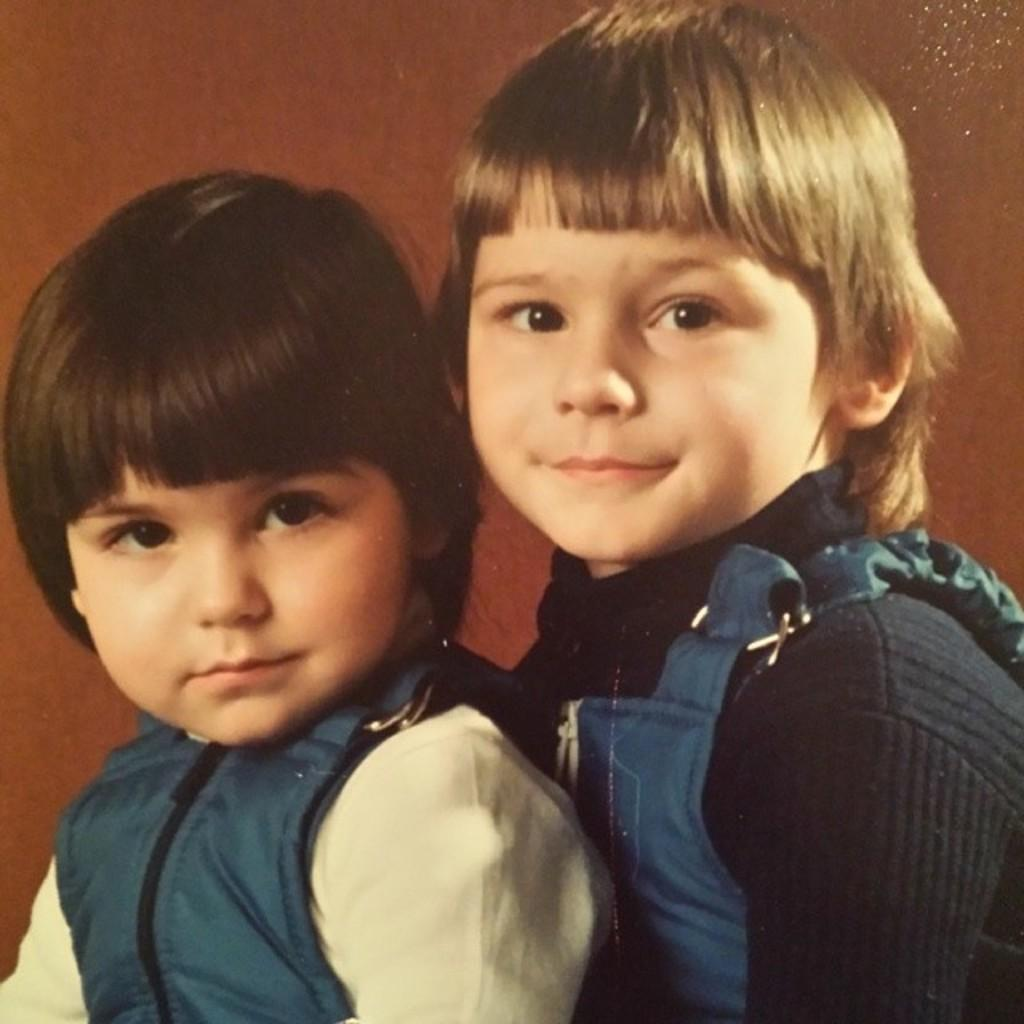How many children are present in the image? There are two kids in the image. What can be seen in the background of the image? The background of the image is brown. What type of star can be seen in the image? There is no star present in the image. What is the smell like in the image? The image does not convey any information about smells, so it cannot be determined from the image. 